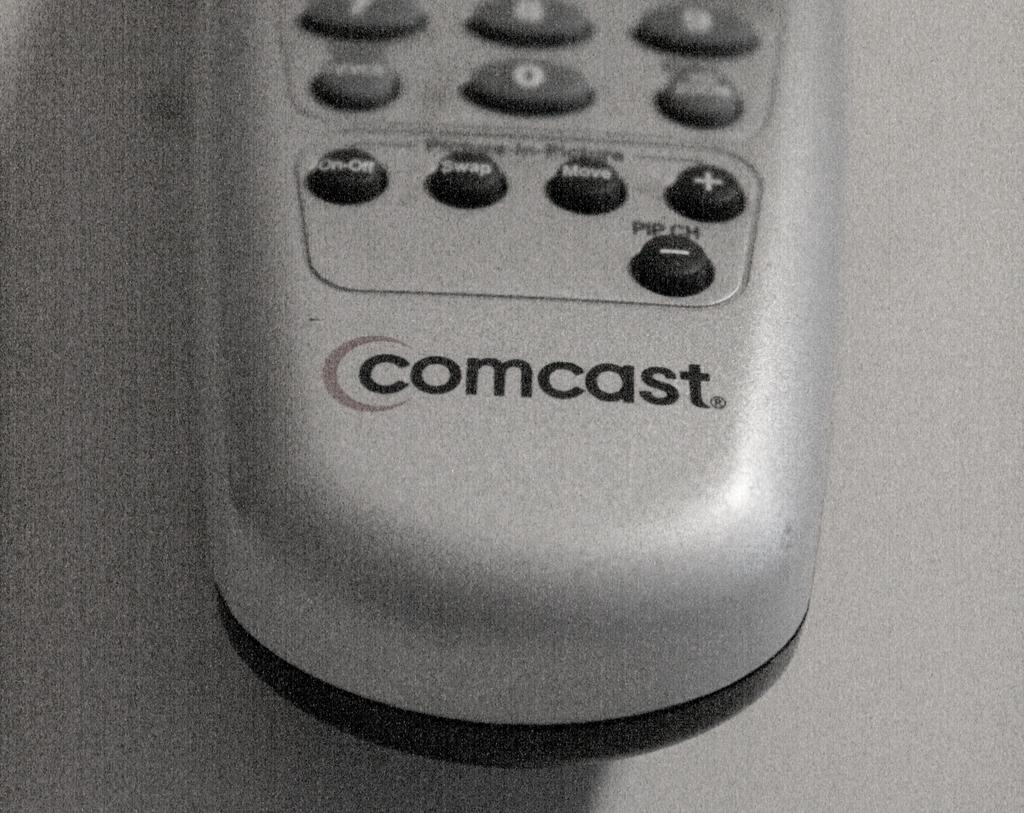<image>
Render a clear and concise summary of the photo. A white Comcast remote control with black and grey buttons. 